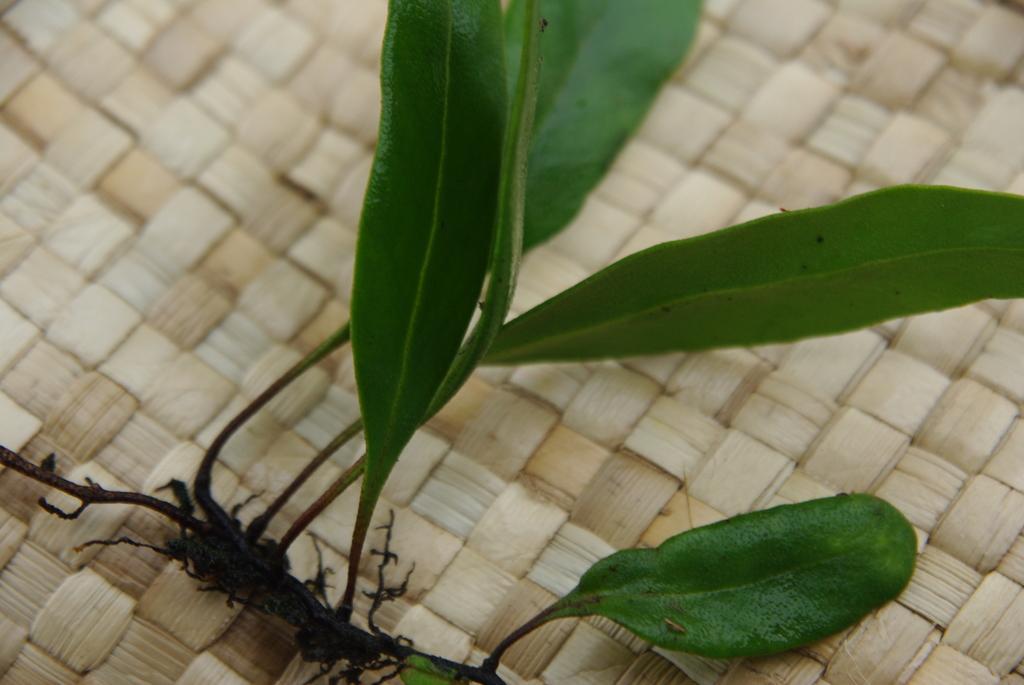Describe this image in one or two sentences. At the bottom of this image, there is a plant having green color leaves. This plant is placed on a surface. 